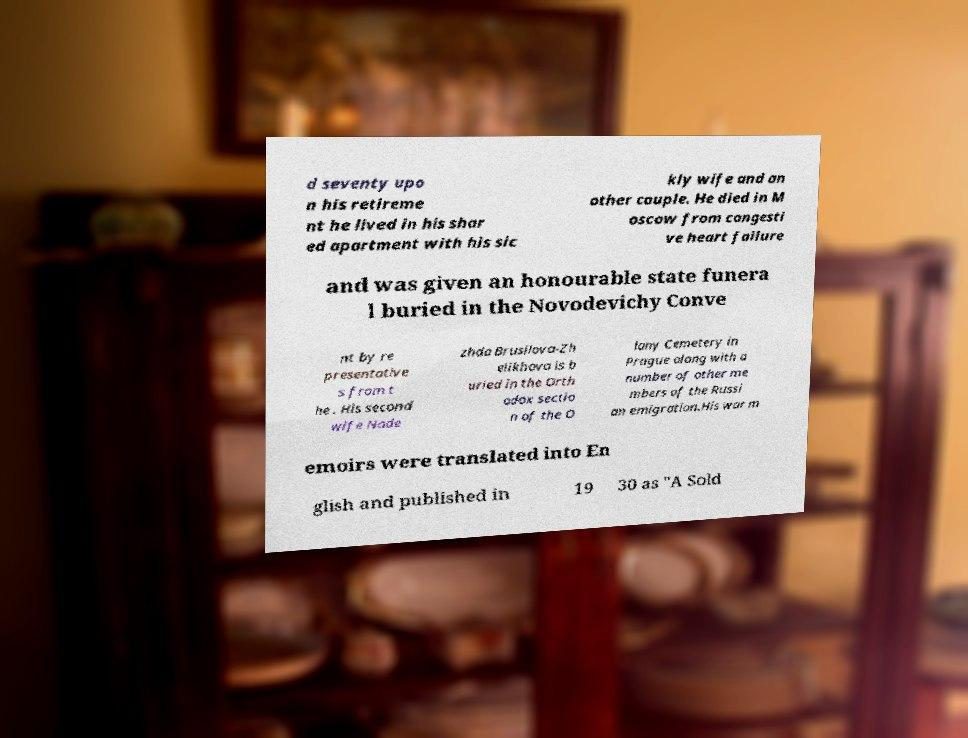Could you extract and type out the text from this image? d seventy upo n his retireme nt he lived in his shar ed apartment with his sic kly wife and an other couple. He died in M oscow from congesti ve heart failure and was given an honourable state funera l buried in the Novodevichy Conve nt by re presentative s from t he . His second wife Nade zhda Brusilova-Zh elikhova is b uried in the Orth odox sectio n of the O lany Cemetery in Prague along with a number of other me mbers of the Russi an emigration.His war m emoirs were translated into En glish and published in 19 30 as "A Sold 